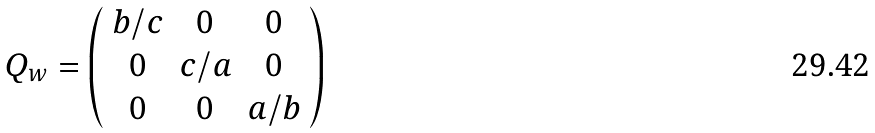Convert formula to latex. <formula><loc_0><loc_0><loc_500><loc_500>Q _ { w } = \left ( \begin{array} { c c c } b / c & 0 & 0 \\ 0 & c / a & 0 \\ 0 & 0 & a / b \end{array} \right )</formula> 